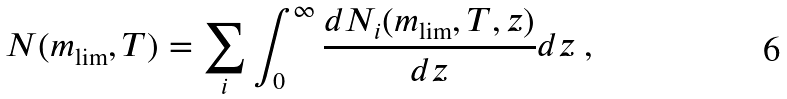Convert formula to latex. <formula><loc_0><loc_0><loc_500><loc_500>N ( m _ { \lim } , T ) = \sum _ { i } \int _ { 0 } ^ { \infty } \frac { d N _ { i } ( m _ { \lim } , T , z ) } { d z } d z \ ,</formula> 